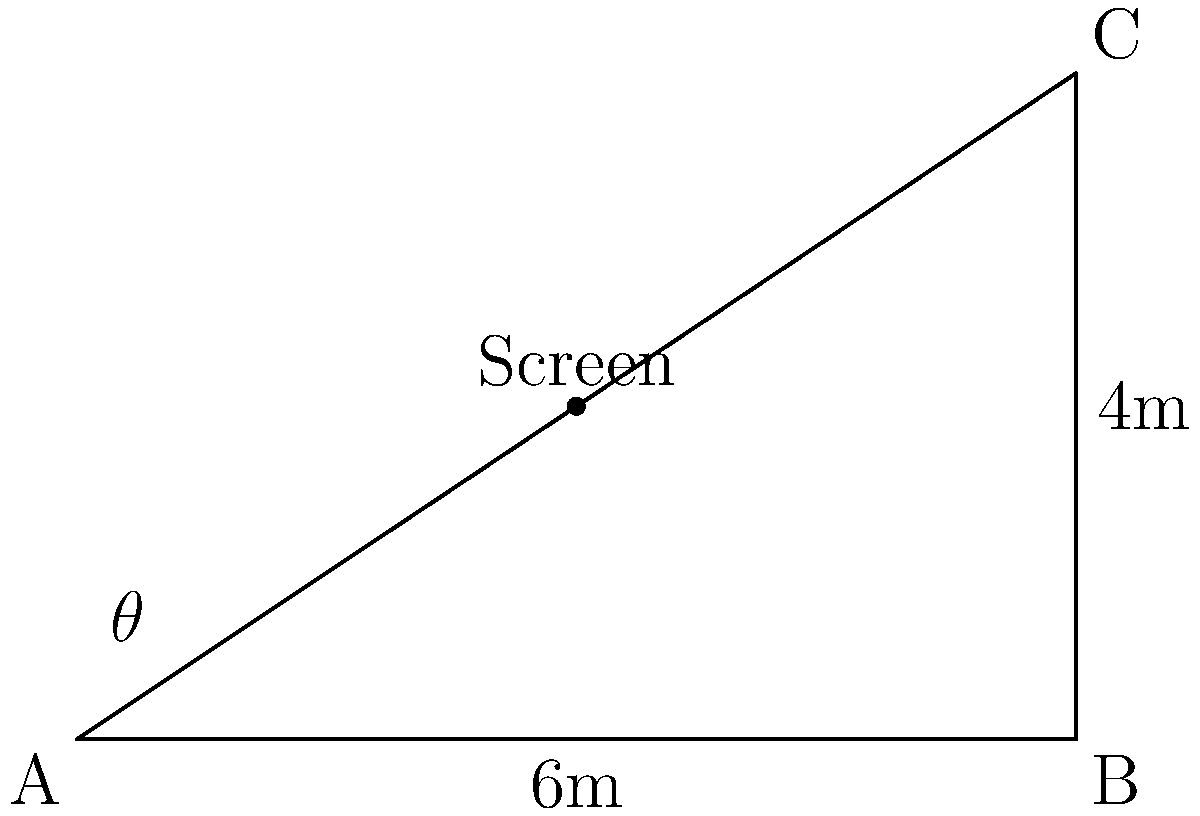In a telemedicine consultation room, a screen needs to be positioned for optimal viewing. The room has a right-angled corner with dimensions 6m by 4m. If the screen is placed at the midpoint of the hypotenuse, at what angle $\theta$ should a camera be tilted up from the horizontal to directly face the screen? Let's approach this step-by-step:

1) First, we need to find the length of the hypotenuse (AC) using the Pythagorean theorem:
   $$AC^2 = 6^2 + 4^2 = 36 + 16 = 52$$
   $$AC = \sqrt{52} = 2\sqrt{13}$$

2) The screen is placed at the midpoint of the hypotenuse. So, the distance from point A to the screen is half of AC:
   $$\text{Distance to screen} = \frac{AC}{2} = \frac{2\sqrt{13}}{2} = \sqrt{13}$$

3) Now we have a right-angled triangle with:
   - Base (adjacent to $\theta$) = 3m (half of the room width)
   - Height (opposite to $\theta$) = 2m (half of the room height)
   - Hypotenuse = $\sqrt{13}$m (distance to screen)

4) We can use the tangent ratio to find $\theta$:
   $$\tan \theta = \frac{\text{opposite}}{\text{adjacent}} = \frac{2}{3}$$

5) Therefore:
   $$\theta = \arctan(\frac{2}{3})$$

6) Converting to degrees:
   $$\theta \approx 33.69°$$

The camera should be tilted up at approximately 33.69° from the horizontal to directly face the screen.
Answer: $\arctan(\frac{2}{3})$ or approximately 33.69° 